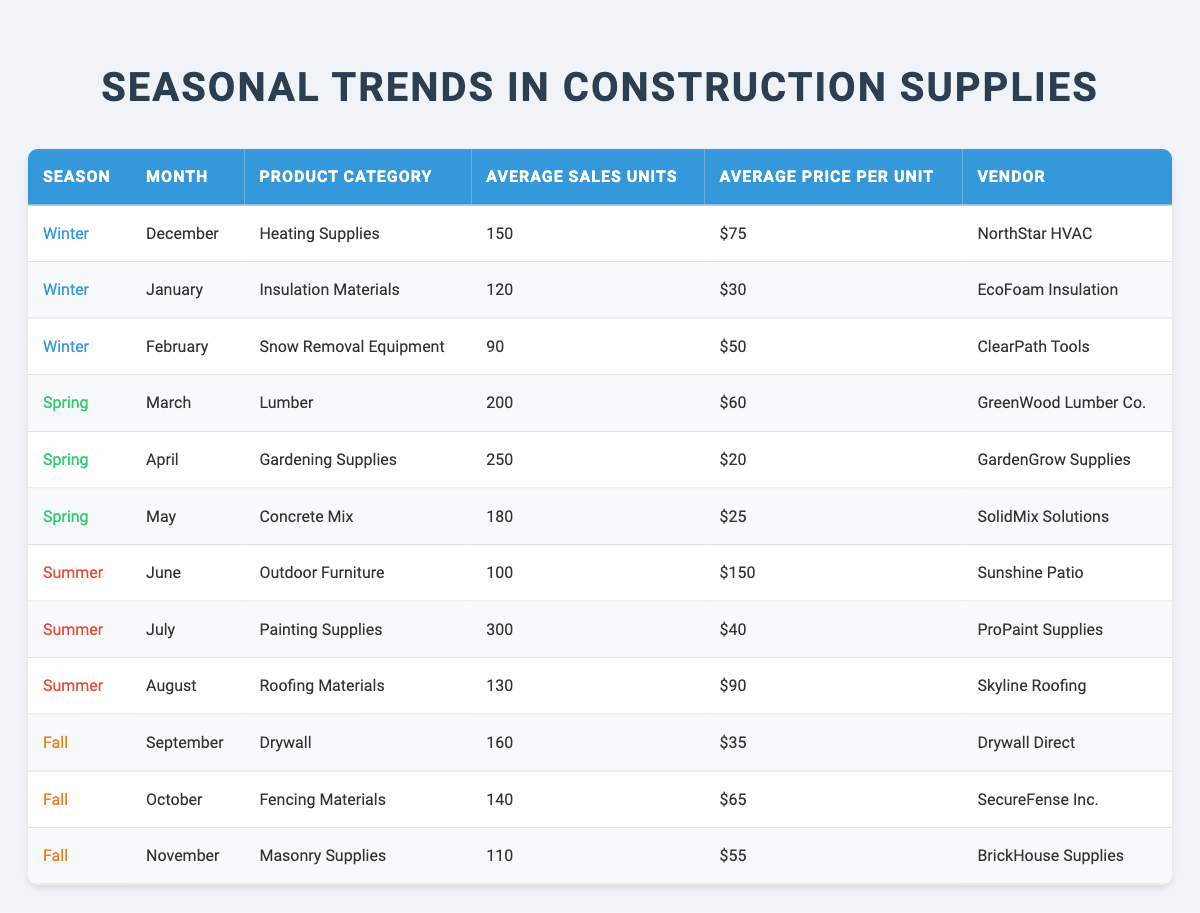What product category had the highest average sales units in Spring? In Spring, the product categories and their average sales units are: Lumber (200), Gardening Supplies (250), and Concrete Mix (180). The highest value is 250 units from Gardening Supplies.
Answer: Gardening Supplies Which vendor sold the most units of Painting Supplies in Summer? The only vendor listed for Painting Supplies in Summer is ProPaint Supplies, which sold 300 units in July.
Answer: ProPaint Supplies In which month do Heating Supplies sell the most? Based on the data, Heating Supplies sold 150 units in December, and it's the only month Heating Supplies is listed, making it the month with the most sales for this category.
Answer: December What is the average price per unit of Concrete Mix in Spring? The average price per unit for Concrete Mix, as shown in the table, is $25. This value can be taken directly from the data.
Answer: $25 Do vendors in Winter sell more units than those in Fall? In Winter, the total sales units are 150 + 120 + 90 = 360, while in Fall, they are 160 + 140 + 110 = 410. Since 360 is less than 410, vendors in Winter do not sell more units.
Answer: No What is the total average sales units for all product categories in Summer? In Summer, the categories are Outdoor Furniture (100), Painting Supplies (300), and Roofing Materials (130). Summing these gives 100 + 300 + 130 = 530 total units.
Answer: 530 Is there a month where both Heating Supplies and Concrete Mix are sold? Heating Supplies is only sold in December, while Concrete Mix is only sold in May, meaning there is no overlap in months for these two categories.
Answer: No What is the difference in average sales units between July's Painting Supplies and December's Heating Supplies? July's Painting Supplies sold 300 units while December's Heating Supplies sold 150 units. The difference is 300 - 150 = 150.
Answer: 150 Which season had the lowest average price per unit among its products? Evaluating the average prices per season: Winter (average of 75, 30, 50), Spring (average of 60, 20, 25), Summer (average of 150, 40, 90), and Fall (average of 35, 65, 55) gives averages of 51.67 for Winter, 35 for Spring, 93.33 for Summer, and 51.67 for Fall. Spring has the lowest average price.
Answer: Spring 